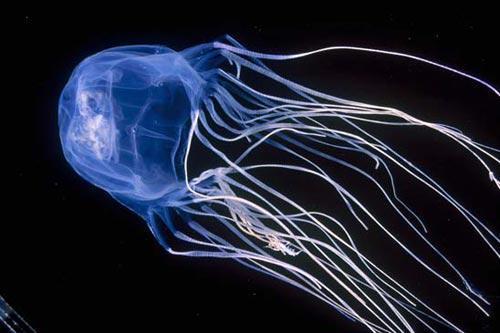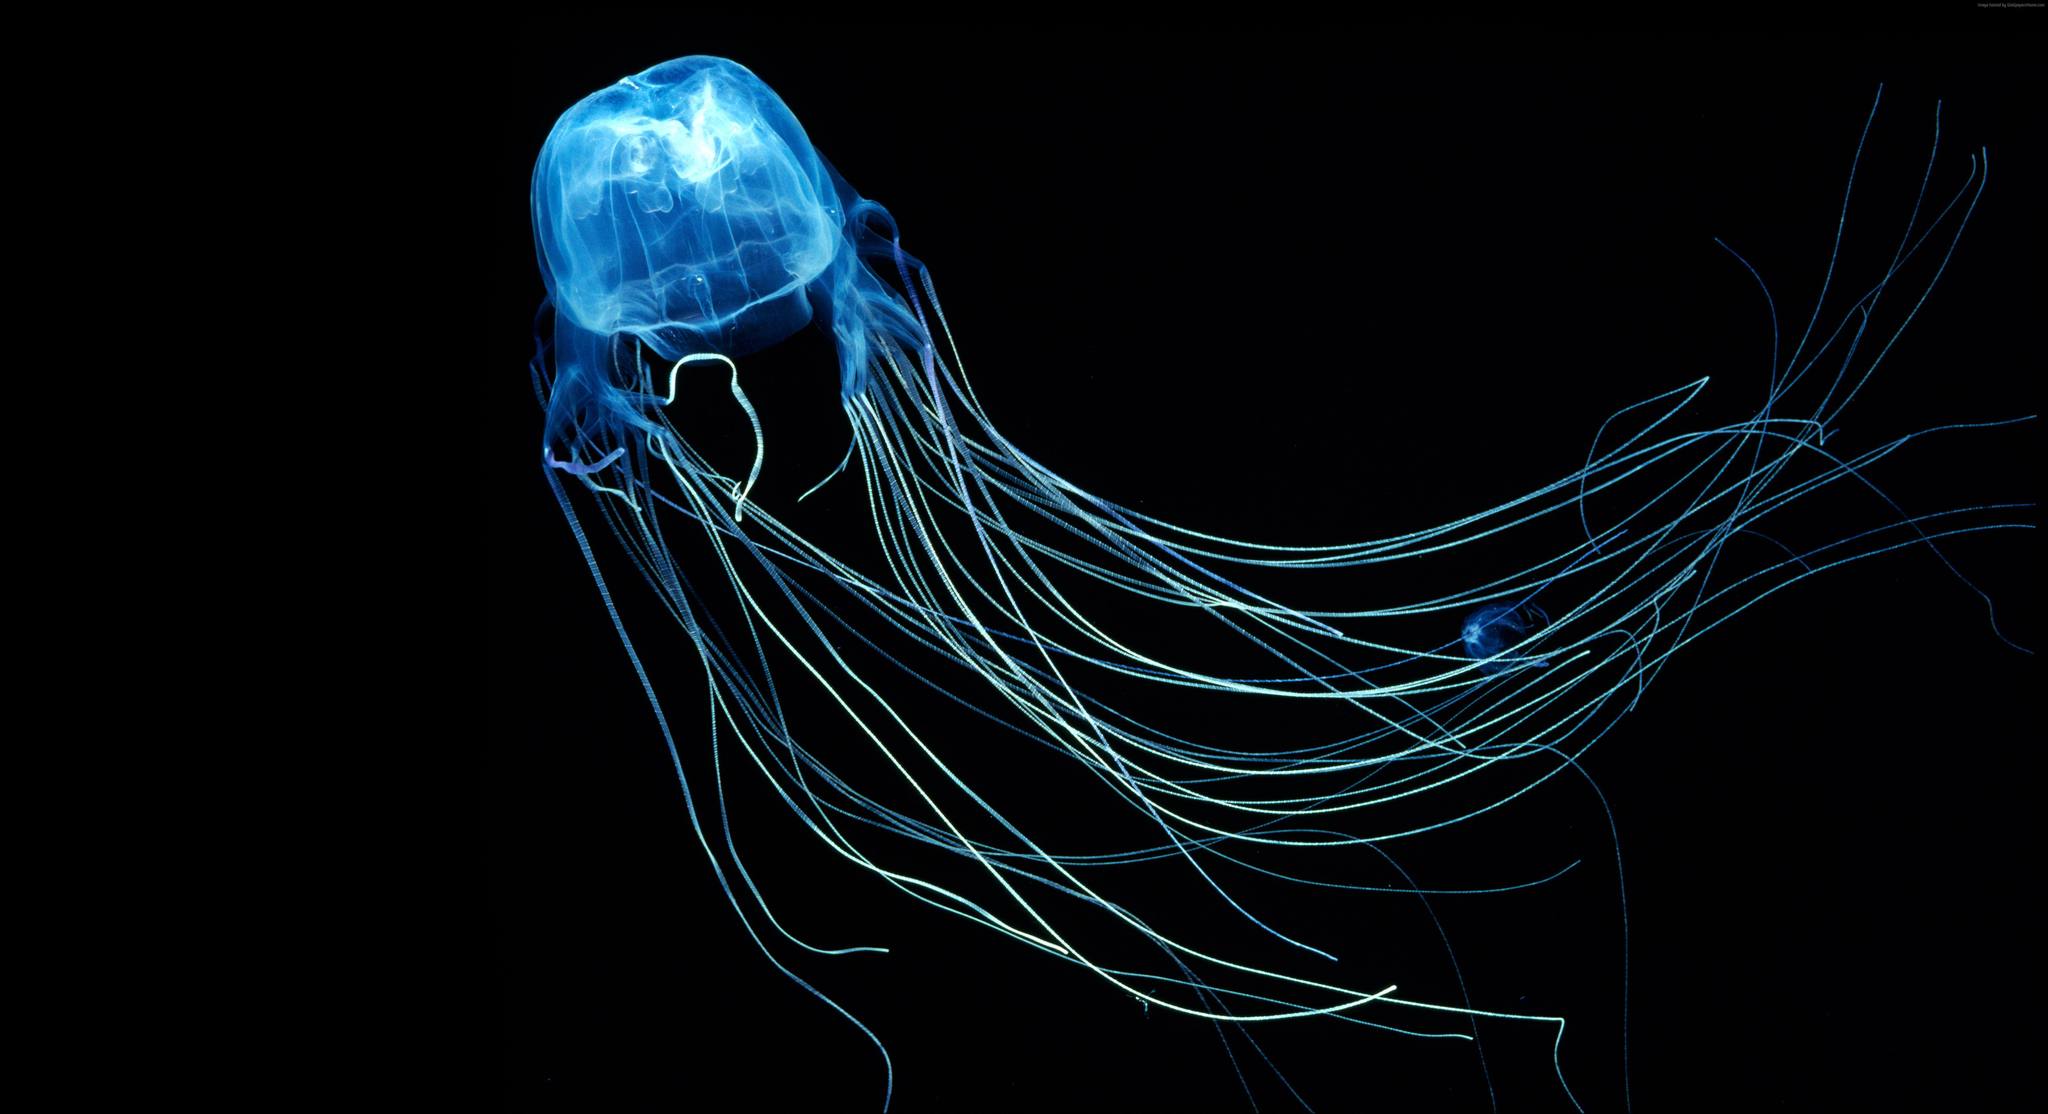The first image is the image on the left, the second image is the image on the right. For the images shown, is this caption "The jellyfish is swimming to the left in the image on the left" true? Answer yes or no. Yes. 